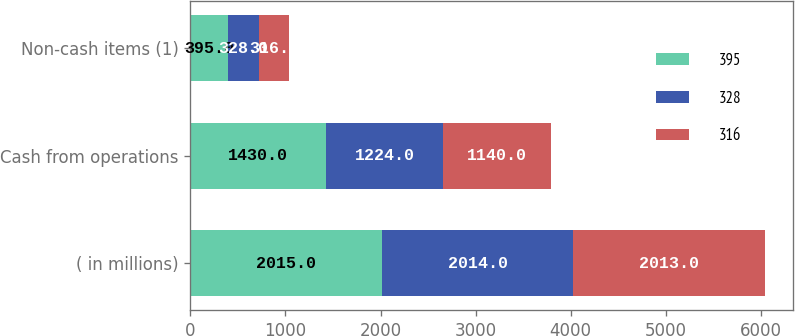<chart> <loc_0><loc_0><loc_500><loc_500><stacked_bar_chart><ecel><fcel>( in millions)<fcel>Cash from operations<fcel>Non-cash items (1)<nl><fcel>395<fcel>2015<fcel>1430<fcel>395<nl><fcel>328<fcel>2014<fcel>1224<fcel>328<nl><fcel>316<fcel>2013<fcel>1140<fcel>316<nl></chart> 